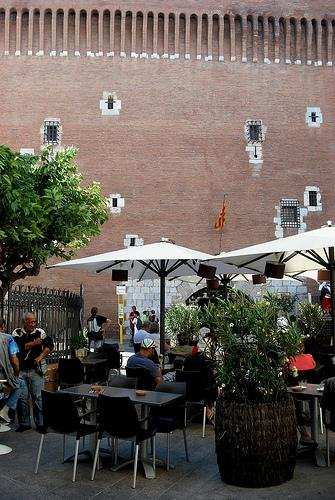Question: why are umbrellas probably over tables?
Choices:
A. Decoration.
B. So tables don't get wet.
C. For shade.
D. They came with the tables.
Answer with the letter. Answer: C Question: where is this photo would people sit?
Choices:
A. Couch.
B. The ground.
C. Chairs.
D. The porch.
Answer with the letter. Answer: C Question: what does the building in background appear to be constructed of?
Choices:
A. Wood.
B. Cement.
C. Metal.
D. Bricks.
Answer with the letter. Answer: D Question: what color are the bricks?
Choices:
A. Crimson.
B. Terra cotta.
C. Rose.
D. Chocolate brown.
Answer with the letter. Answer: C 